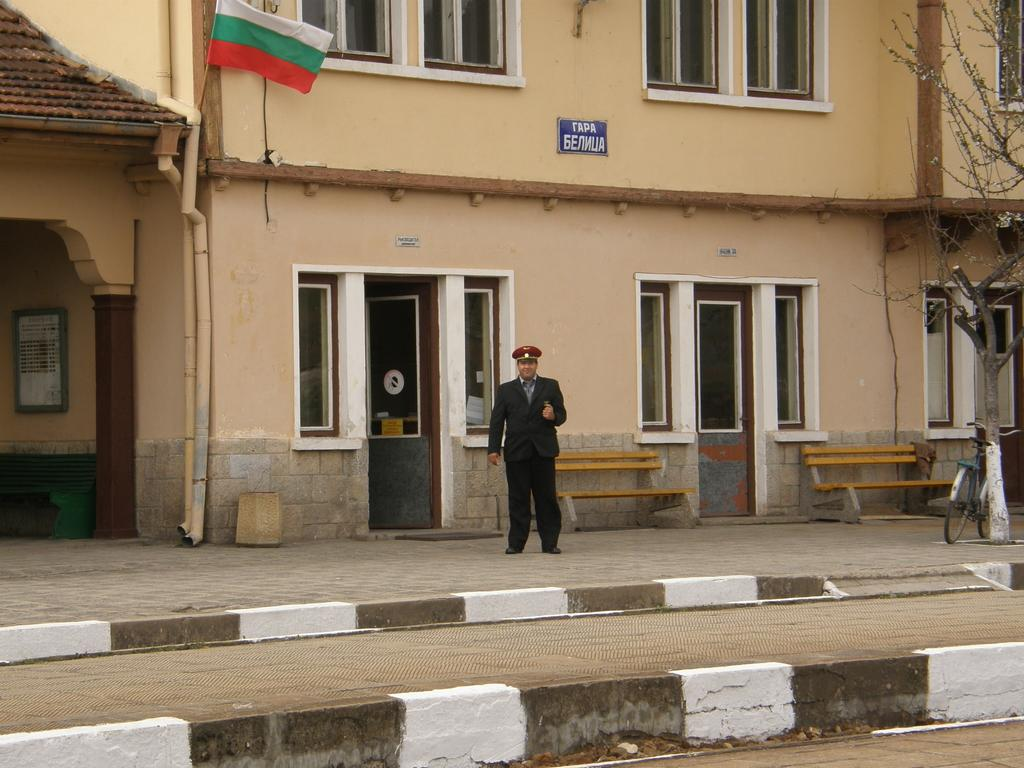What is the main subject of the image? There is a man standing in the image. Can you describe the man's attire? The man is wearing a hat. What can be seen in the background of the image? There is a building, a flag, a tree, a bicycle, benches, and other objects in the background of the image. What type of pot can be seen in the image? There is no pot present in the image. What does the image smell like? The image does not have a smell, as it is a visual representation. 